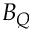<formula> <loc_0><loc_0><loc_500><loc_500>B _ { Q }</formula> 